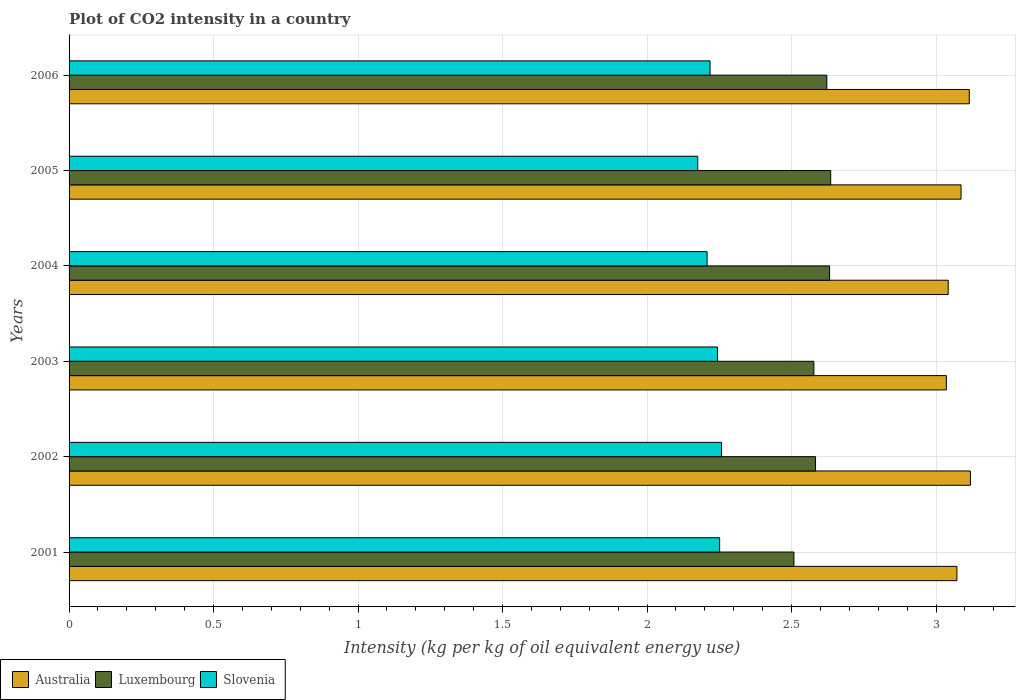How many groups of bars are there?
Your response must be concise. 6. Are the number of bars on each tick of the Y-axis equal?
Give a very brief answer. Yes. How many bars are there on the 3rd tick from the top?
Your answer should be compact. 3. In how many cases, is the number of bars for a given year not equal to the number of legend labels?
Ensure brevity in your answer.  0. What is the CO2 intensity in in Australia in 2001?
Keep it short and to the point. 3.07. Across all years, what is the maximum CO2 intensity in in Australia?
Your response must be concise. 3.12. Across all years, what is the minimum CO2 intensity in in Luxembourg?
Ensure brevity in your answer.  2.51. In which year was the CO2 intensity in in Luxembourg maximum?
Offer a very short reply. 2005. What is the total CO2 intensity in in Australia in the graph?
Your answer should be compact. 18.47. What is the difference between the CO2 intensity in in Slovenia in 2002 and that in 2006?
Your answer should be very brief. 0.04. What is the difference between the CO2 intensity in in Luxembourg in 2004 and the CO2 intensity in in Slovenia in 2006?
Offer a very short reply. 0.41. What is the average CO2 intensity in in Australia per year?
Provide a succinct answer. 3.08. In the year 2004, what is the difference between the CO2 intensity in in Luxembourg and CO2 intensity in in Australia?
Give a very brief answer. -0.41. What is the ratio of the CO2 intensity in in Slovenia in 2004 to that in 2006?
Ensure brevity in your answer.  1. Is the CO2 intensity in in Luxembourg in 2001 less than that in 2003?
Provide a succinct answer. Yes. What is the difference between the highest and the second highest CO2 intensity in in Luxembourg?
Provide a succinct answer. 0. What is the difference between the highest and the lowest CO2 intensity in in Australia?
Offer a very short reply. 0.08. In how many years, is the CO2 intensity in in Australia greater than the average CO2 intensity in in Australia taken over all years?
Ensure brevity in your answer.  3. What does the 2nd bar from the top in 2003 represents?
Provide a short and direct response. Luxembourg. What does the 2nd bar from the bottom in 2003 represents?
Your response must be concise. Luxembourg. Is it the case that in every year, the sum of the CO2 intensity in in Australia and CO2 intensity in in Luxembourg is greater than the CO2 intensity in in Slovenia?
Keep it short and to the point. Yes. Are all the bars in the graph horizontal?
Your response must be concise. Yes. What is the difference between two consecutive major ticks on the X-axis?
Make the answer very short. 0.5. Where does the legend appear in the graph?
Make the answer very short. Bottom left. How many legend labels are there?
Keep it short and to the point. 3. How are the legend labels stacked?
Ensure brevity in your answer.  Horizontal. What is the title of the graph?
Ensure brevity in your answer.  Plot of CO2 intensity in a country. What is the label or title of the X-axis?
Provide a short and direct response. Intensity (kg per kg of oil equivalent energy use). What is the label or title of the Y-axis?
Offer a very short reply. Years. What is the Intensity (kg per kg of oil equivalent energy use) in Australia in 2001?
Your answer should be compact. 3.07. What is the Intensity (kg per kg of oil equivalent energy use) of Luxembourg in 2001?
Your response must be concise. 2.51. What is the Intensity (kg per kg of oil equivalent energy use) of Slovenia in 2001?
Provide a short and direct response. 2.25. What is the Intensity (kg per kg of oil equivalent energy use) in Australia in 2002?
Keep it short and to the point. 3.12. What is the Intensity (kg per kg of oil equivalent energy use) in Luxembourg in 2002?
Make the answer very short. 2.58. What is the Intensity (kg per kg of oil equivalent energy use) of Slovenia in 2002?
Provide a short and direct response. 2.26. What is the Intensity (kg per kg of oil equivalent energy use) of Australia in 2003?
Keep it short and to the point. 3.04. What is the Intensity (kg per kg of oil equivalent energy use) of Luxembourg in 2003?
Make the answer very short. 2.58. What is the Intensity (kg per kg of oil equivalent energy use) in Slovenia in 2003?
Your response must be concise. 2.24. What is the Intensity (kg per kg of oil equivalent energy use) of Australia in 2004?
Your answer should be compact. 3.04. What is the Intensity (kg per kg of oil equivalent energy use) of Luxembourg in 2004?
Your answer should be compact. 2.63. What is the Intensity (kg per kg of oil equivalent energy use) in Slovenia in 2004?
Give a very brief answer. 2.21. What is the Intensity (kg per kg of oil equivalent energy use) of Australia in 2005?
Ensure brevity in your answer.  3.09. What is the Intensity (kg per kg of oil equivalent energy use) in Luxembourg in 2005?
Offer a terse response. 2.64. What is the Intensity (kg per kg of oil equivalent energy use) in Slovenia in 2005?
Provide a succinct answer. 2.18. What is the Intensity (kg per kg of oil equivalent energy use) of Australia in 2006?
Offer a terse response. 3.12. What is the Intensity (kg per kg of oil equivalent energy use) in Luxembourg in 2006?
Your answer should be very brief. 2.62. What is the Intensity (kg per kg of oil equivalent energy use) of Slovenia in 2006?
Keep it short and to the point. 2.22. Across all years, what is the maximum Intensity (kg per kg of oil equivalent energy use) in Australia?
Give a very brief answer. 3.12. Across all years, what is the maximum Intensity (kg per kg of oil equivalent energy use) of Luxembourg?
Make the answer very short. 2.64. Across all years, what is the maximum Intensity (kg per kg of oil equivalent energy use) of Slovenia?
Your answer should be very brief. 2.26. Across all years, what is the minimum Intensity (kg per kg of oil equivalent energy use) of Australia?
Keep it short and to the point. 3.04. Across all years, what is the minimum Intensity (kg per kg of oil equivalent energy use) in Luxembourg?
Your answer should be compact. 2.51. Across all years, what is the minimum Intensity (kg per kg of oil equivalent energy use) in Slovenia?
Provide a succinct answer. 2.18. What is the total Intensity (kg per kg of oil equivalent energy use) in Australia in the graph?
Keep it short and to the point. 18.47. What is the total Intensity (kg per kg of oil equivalent energy use) in Luxembourg in the graph?
Offer a terse response. 15.56. What is the total Intensity (kg per kg of oil equivalent energy use) in Slovenia in the graph?
Your response must be concise. 13.35. What is the difference between the Intensity (kg per kg of oil equivalent energy use) in Australia in 2001 and that in 2002?
Ensure brevity in your answer.  -0.05. What is the difference between the Intensity (kg per kg of oil equivalent energy use) of Luxembourg in 2001 and that in 2002?
Provide a short and direct response. -0.07. What is the difference between the Intensity (kg per kg of oil equivalent energy use) in Slovenia in 2001 and that in 2002?
Ensure brevity in your answer.  -0.01. What is the difference between the Intensity (kg per kg of oil equivalent energy use) in Australia in 2001 and that in 2003?
Your response must be concise. 0.04. What is the difference between the Intensity (kg per kg of oil equivalent energy use) of Luxembourg in 2001 and that in 2003?
Make the answer very short. -0.07. What is the difference between the Intensity (kg per kg of oil equivalent energy use) in Slovenia in 2001 and that in 2003?
Ensure brevity in your answer.  0.01. What is the difference between the Intensity (kg per kg of oil equivalent energy use) of Australia in 2001 and that in 2004?
Give a very brief answer. 0.03. What is the difference between the Intensity (kg per kg of oil equivalent energy use) in Luxembourg in 2001 and that in 2004?
Offer a very short reply. -0.12. What is the difference between the Intensity (kg per kg of oil equivalent energy use) of Slovenia in 2001 and that in 2004?
Keep it short and to the point. 0.04. What is the difference between the Intensity (kg per kg of oil equivalent energy use) of Australia in 2001 and that in 2005?
Offer a terse response. -0.01. What is the difference between the Intensity (kg per kg of oil equivalent energy use) of Luxembourg in 2001 and that in 2005?
Provide a short and direct response. -0.13. What is the difference between the Intensity (kg per kg of oil equivalent energy use) in Slovenia in 2001 and that in 2005?
Your response must be concise. 0.08. What is the difference between the Intensity (kg per kg of oil equivalent energy use) in Australia in 2001 and that in 2006?
Offer a very short reply. -0.04. What is the difference between the Intensity (kg per kg of oil equivalent energy use) in Luxembourg in 2001 and that in 2006?
Provide a succinct answer. -0.11. What is the difference between the Intensity (kg per kg of oil equivalent energy use) in Slovenia in 2001 and that in 2006?
Offer a very short reply. 0.03. What is the difference between the Intensity (kg per kg of oil equivalent energy use) in Australia in 2002 and that in 2003?
Keep it short and to the point. 0.08. What is the difference between the Intensity (kg per kg of oil equivalent energy use) in Luxembourg in 2002 and that in 2003?
Provide a short and direct response. 0.01. What is the difference between the Intensity (kg per kg of oil equivalent energy use) of Slovenia in 2002 and that in 2003?
Keep it short and to the point. 0.01. What is the difference between the Intensity (kg per kg of oil equivalent energy use) of Australia in 2002 and that in 2004?
Provide a succinct answer. 0.08. What is the difference between the Intensity (kg per kg of oil equivalent energy use) in Luxembourg in 2002 and that in 2004?
Provide a succinct answer. -0.05. What is the difference between the Intensity (kg per kg of oil equivalent energy use) of Slovenia in 2002 and that in 2004?
Your answer should be compact. 0.05. What is the difference between the Intensity (kg per kg of oil equivalent energy use) of Australia in 2002 and that in 2005?
Offer a terse response. 0.03. What is the difference between the Intensity (kg per kg of oil equivalent energy use) in Luxembourg in 2002 and that in 2005?
Your answer should be very brief. -0.05. What is the difference between the Intensity (kg per kg of oil equivalent energy use) in Slovenia in 2002 and that in 2005?
Offer a very short reply. 0.08. What is the difference between the Intensity (kg per kg of oil equivalent energy use) of Australia in 2002 and that in 2006?
Offer a terse response. 0. What is the difference between the Intensity (kg per kg of oil equivalent energy use) of Luxembourg in 2002 and that in 2006?
Your answer should be compact. -0.04. What is the difference between the Intensity (kg per kg of oil equivalent energy use) of Slovenia in 2002 and that in 2006?
Ensure brevity in your answer.  0.04. What is the difference between the Intensity (kg per kg of oil equivalent energy use) of Australia in 2003 and that in 2004?
Give a very brief answer. -0.01. What is the difference between the Intensity (kg per kg of oil equivalent energy use) of Luxembourg in 2003 and that in 2004?
Provide a succinct answer. -0.05. What is the difference between the Intensity (kg per kg of oil equivalent energy use) in Slovenia in 2003 and that in 2004?
Your answer should be compact. 0.04. What is the difference between the Intensity (kg per kg of oil equivalent energy use) in Australia in 2003 and that in 2005?
Provide a short and direct response. -0.05. What is the difference between the Intensity (kg per kg of oil equivalent energy use) in Luxembourg in 2003 and that in 2005?
Keep it short and to the point. -0.06. What is the difference between the Intensity (kg per kg of oil equivalent energy use) in Slovenia in 2003 and that in 2005?
Offer a terse response. 0.07. What is the difference between the Intensity (kg per kg of oil equivalent energy use) in Australia in 2003 and that in 2006?
Offer a very short reply. -0.08. What is the difference between the Intensity (kg per kg of oil equivalent energy use) of Luxembourg in 2003 and that in 2006?
Ensure brevity in your answer.  -0.04. What is the difference between the Intensity (kg per kg of oil equivalent energy use) in Slovenia in 2003 and that in 2006?
Provide a short and direct response. 0.03. What is the difference between the Intensity (kg per kg of oil equivalent energy use) of Australia in 2004 and that in 2005?
Give a very brief answer. -0.04. What is the difference between the Intensity (kg per kg of oil equivalent energy use) of Luxembourg in 2004 and that in 2005?
Your answer should be very brief. -0. What is the difference between the Intensity (kg per kg of oil equivalent energy use) of Slovenia in 2004 and that in 2005?
Your answer should be compact. 0.03. What is the difference between the Intensity (kg per kg of oil equivalent energy use) of Australia in 2004 and that in 2006?
Provide a succinct answer. -0.07. What is the difference between the Intensity (kg per kg of oil equivalent energy use) in Luxembourg in 2004 and that in 2006?
Ensure brevity in your answer.  0.01. What is the difference between the Intensity (kg per kg of oil equivalent energy use) of Slovenia in 2004 and that in 2006?
Offer a terse response. -0.01. What is the difference between the Intensity (kg per kg of oil equivalent energy use) in Australia in 2005 and that in 2006?
Your answer should be compact. -0.03. What is the difference between the Intensity (kg per kg of oil equivalent energy use) of Luxembourg in 2005 and that in 2006?
Provide a succinct answer. 0.01. What is the difference between the Intensity (kg per kg of oil equivalent energy use) of Slovenia in 2005 and that in 2006?
Your response must be concise. -0.04. What is the difference between the Intensity (kg per kg of oil equivalent energy use) in Australia in 2001 and the Intensity (kg per kg of oil equivalent energy use) in Luxembourg in 2002?
Your answer should be very brief. 0.49. What is the difference between the Intensity (kg per kg of oil equivalent energy use) in Australia in 2001 and the Intensity (kg per kg of oil equivalent energy use) in Slovenia in 2002?
Give a very brief answer. 0.81. What is the difference between the Intensity (kg per kg of oil equivalent energy use) of Luxembourg in 2001 and the Intensity (kg per kg of oil equivalent energy use) of Slovenia in 2002?
Give a very brief answer. 0.25. What is the difference between the Intensity (kg per kg of oil equivalent energy use) in Australia in 2001 and the Intensity (kg per kg of oil equivalent energy use) in Luxembourg in 2003?
Your answer should be compact. 0.49. What is the difference between the Intensity (kg per kg of oil equivalent energy use) of Australia in 2001 and the Intensity (kg per kg of oil equivalent energy use) of Slovenia in 2003?
Give a very brief answer. 0.83. What is the difference between the Intensity (kg per kg of oil equivalent energy use) of Luxembourg in 2001 and the Intensity (kg per kg of oil equivalent energy use) of Slovenia in 2003?
Make the answer very short. 0.26. What is the difference between the Intensity (kg per kg of oil equivalent energy use) of Australia in 2001 and the Intensity (kg per kg of oil equivalent energy use) of Luxembourg in 2004?
Offer a very short reply. 0.44. What is the difference between the Intensity (kg per kg of oil equivalent energy use) in Australia in 2001 and the Intensity (kg per kg of oil equivalent energy use) in Slovenia in 2004?
Offer a very short reply. 0.86. What is the difference between the Intensity (kg per kg of oil equivalent energy use) of Luxembourg in 2001 and the Intensity (kg per kg of oil equivalent energy use) of Slovenia in 2004?
Provide a short and direct response. 0.3. What is the difference between the Intensity (kg per kg of oil equivalent energy use) of Australia in 2001 and the Intensity (kg per kg of oil equivalent energy use) of Luxembourg in 2005?
Ensure brevity in your answer.  0.44. What is the difference between the Intensity (kg per kg of oil equivalent energy use) of Australia in 2001 and the Intensity (kg per kg of oil equivalent energy use) of Slovenia in 2005?
Provide a succinct answer. 0.9. What is the difference between the Intensity (kg per kg of oil equivalent energy use) of Luxembourg in 2001 and the Intensity (kg per kg of oil equivalent energy use) of Slovenia in 2005?
Make the answer very short. 0.33. What is the difference between the Intensity (kg per kg of oil equivalent energy use) of Australia in 2001 and the Intensity (kg per kg of oil equivalent energy use) of Luxembourg in 2006?
Your response must be concise. 0.45. What is the difference between the Intensity (kg per kg of oil equivalent energy use) of Australia in 2001 and the Intensity (kg per kg of oil equivalent energy use) of Slovenia in 2006?
Offer a very short reply. 0.85. What is the difference between the Intensity (kg per kg of oil equivalent energy use) in Luxembourg in 2001 and the Intensity (kg per kg of oil equivalent energy use) in Slovenia in 2006?
Your answer should be compact. 0.29. What is the difference between the Intensity (kg per kg of oil equivalent energy use) in Australia in 2002 and the Intensity (kg per kg of oil equivalent energy use) in Luxembourg in 2003?
Your answer should be very brief. 0.54. What is the difference between the Intensity (kg per kg of oil equivalent energy use) in Australia in 2002 and the Intensity (kg per kg of oil equivalent energy use) in Slovenia in 2003?
Give a very brief answer. 0.88. What is the difference between the Intensity (kg per kg of oil equivalent energy use) of Luxembourg in 2002 and the Intensity (kg per kg of oil equivalent energy use) of Slovenia in 2003?
Your answer should be compact. 0.34. What is the difference between the Intensity (kg per kg of oil equivalent energy use) of Australia in 2002 and the Intensity (kg per kg of oil equivalent energy use) of Luxembourg in 2004?
Provide a succinct answer. 0.49. What is the difference between the Intensity (kg per kg of oil equivalent energy use) in Australia in 2002 and the Intensity (kg per kg of oil equivalent energy use) in Slovenia in 2004?
Offer a very short reply. 0.91. What is the difference between the Intensity (kg per kg of oil equivalent energy use) of Luxembourg in 2002 and the Intensity (kg per kg of oil equivalent energy use) of Slovenia in 2004?
Your answer should be very brief. 0.38. What is the difference between the Intensity (kg per kg of oil equivalent energy use) of Australia in 2002 and the Intensity (kg per kg of oil equivalent energy use) of Luxembourg in 2005?
Provide a succinct answer. 0.48. What is the difference between the Intensity (kg per kg of oil equivalent energy use) in Australia in 2002 and the Intensity (kg per kg of oil equivalent energy use) in Slovenia in 2005?
Keep it short and to the point. 0.94. What is the difference between the Intensity (kg per kg of oil equivalent energy use) in Luxembourg in 2002 and the Intensity (kg per kg of oil equivalent energy use) in Slovenia in 2005?
Ensure brevity in your answer.  0.41. What is the difference between the Intensity (kg per kg of oil equivalent energy use) of Australia in 2002 and the Intensity (kg per kg of oil equivalent energy use) of Luxembourg in 2006?
Ensure brevity in your answer.  0.5. What is the difference between the Intensity (kg per kg of oil equivalent energy use) in Australia in 2002 and the Intensity (kg per kg of oil equivalent energy use) in Slovenia in 2006?
Offer a very short reply. 0.9. What is the difference between the Intensity (kg per kg of oil equivalent energy use) of Luxembourg in 2002 and the Intensity (kg per kg of oil equivalent energy use) of Slovenia in 2006?
Give a very brief answer. 0.37. What is the difference between the Intensity (kg per kg of oil equivalent energy use) in Australia in 2003 and the Intensity (kg per kg of oil equivalent energy use) in Luxembourg in 2004?
Provide a succinct answer. 0.4. What is the difference between the Intensity (kg per kg of oil equivalent energy use) of Australia in 2003 and the Intensity (kg per kg of oil equivalent energy use) of Slovenia in 2004?
Make the answer very short. 0.83. What is the difference between the Intensity (kg per kg of oil equivalent energy use) in Luxembourg in 2003 and the Intensity (kg per kg of oil equivalent energy use) in Slovenia in 2004?
Your answer should be very brief. 0.37. What is the difference between the Intensity (kg per kg of oil equivalent energy use) of Australia in 2003 and the Intensity (kg per kg of oil equivalent energy use) of Luxembourg in 2005?
Provide a succinct answer. 0.4. What is the difference between the Intensity (kg per kg of oil equivalent energy use) in Australia in 2003 and the Intensity (kg per kg of oil equivalent energy use) in Slovenia in 2005?
Ensure brevity in your answer.  0.86. What is the difference between the Intensity (kg per kg of oil equivalent energy use) in Luxembourg in 2003 and the Intensity (kg per kg of oil equivalent energy use) in Slovenia in 2005?
Provide a short and direct response. 0.4. What is the difference between the Intensity (kg per kg of oil equivalent energy use) of Australia in 2003 and the Intensity (kg per kg of oil equivalent energy use) of Luxembourg in 2006?
Your answer should be compact. 0.41. What is the difference between the Intensity (kg per kg of oil equivalent energy use) of Australia in 2003 and the Intensity (kg per kg of oil equivalent energy use) of Slovenia in 2006?
Provide a succinct answer. 0.82. What is the difference between the Intensity (kg per kg of oil equivalent energy use) in Luxembourg in 2003 and the Intensity (kg per kg of oil equivalent energy use) in Slovenia in 2006?
Ensure brevity in your answer.  0.36. What is the difference between the Intensity (kg per kg of oil equivalent energy use) of Australia in 2004 and the Intensity (kg per kg of oil equivalent energy use) of Luxembourg in 2005?
Make the answer very short. 0.41. What is the difference between the Intensity (kg per kg of oil equivalent energy use) in Australia in 2004 and the Intensity (kg per kg of oil equivalent energy use) in Slovenia in 2005?
Your answer should be very brief. 0.87. What is the difference between the Intensity (kg per kg of oil equivalent energy use) in Luxembourg in 2004 and the Intensity (kg per kg of oil equivalent energy use) in Slovenia in 2005?
Provide a short and direct response. 0.46. What is the difference between the Intensity (kg per kg of oil equivalent energy use) in Australia in 2004 and the Intensity (kg per kg of oil equivalent energy use) in Luxembourg in 2006?
Your answer should be compact. 0.42. What is the difference between the Intensity (kg per kg of oil equivalent energy use) in Australia in 2004 and the Intensity (kg per kg of oil equivalent energy use) in Slovenia in 2006?
Your response must be concise. 0.82. What is the difference between the Intensity (kg per kg of oil equivalent energy use) of Luxembourg in 2004 and the Intensity (kg per kg of oil equivalent energy use) of Slovenia in 2006?
Your answer should be very brief. 0.41. What is the difference between the Intensity (kg per kg of oil equivalent energy use) of Australia in 2005 and the Intensity (kg per kg of oil equivalent energy use) of Luxembourg in 2006?
Offer a very short reply. 0.46. What is the difference between the Intensity (kg per kg of oil equivalent energy use) in Australia in 2005 and the Intensity (kg per kg of oil equivalent energy use) in Slovenia in 2006?
Offer a very short reply. 0.87. What is the difference between the Intensity (kg per kg of oil equivalent energy use) of Luxembourg in 2005 and the Intensity (kg per kg of oil equivalent energy use) of Slovenia in 2006?
Provide a short and direct response. 0.42. What is the average Intensity (kg per kg of oil equivalent energy use) in Australia per year?
Provide a short and direct response. 3.08. What is the average Intensity (kg per kg of oil equivalent energy use) of Luxembourg per year?
Your answer should be very brief. 2.59. What is the average Intensity (kg per kg of oil equivalent energy use) in Slovenia per year?
Offer a very short reply. 2.23. In the year 2001, what is the difference between the Intensity (kg per kg of oil equivalent energy use) of Australia and Intensity (kg per kg of oil equivalent energy use) of Luxembourg?
Make the answer very short. 0.56. In the year 2001, what is the difference between the Intensity (kg per kg of oil equivalent energy use) of Australia and Intensity (kg per kg of oil equivalent energy use) of Slovenia?
Provide a short and direct response. 0.82. In the year 2001, what is the difference between the Intensity (kg per kg of oil equivalent energy use) of Luxembourg and Intensity (kg per kg of oil equivalent energy use) of Slovenia?
Keep it short and to the point. 0.26. In the year 2002, what is the difference between the Intensity (kg per kg of oil equivalent energy use) of Australia and Intensity (kg per kg of oil equivalent energy use) of Luxembourg?
Give a very brief answer. 0.54. In the year 2002, what is the difference between the Intensity (kg per kg of oil equivalent energy use) of Australia and Intensity (kg per kg of oil equivalent energy use) of Slovenia?
Offer a terse response. 0.86. In the year 2002, what is the difference between the Intensity (kg per kg of oil equivalent energy use) of Luxembourg and Intensity (kg per kg of oil equivalent energy use) of Slovenia?
Your answer should be very brief. 0.33. In the year 2003, what is the difference between the Intensity (kg per kg of oil equivalent energy use) in Australia and Intensity (kg per kg of oil equivalent energy use) in Luxembourg?
Keep it short and to the point. 0.46. In the year 2003, what is the difference between the Intensity (kg per kg of oil equivalent energy use) of Australia and Intensity (kg per kg of oil equivalent energy use) of Slovenia?
Offer a very short reply. 0.79. In the year 2004, what is the difference between the Intensity (kg per kg of oil equivalent energy use) of Australia and Intensity (kg per kg of oil equivalent energy use) of Luxembourg?
Offer a very short reply. 0.41. In the year 2004, what is the difference between the Intensity (kg per kg of oil equivalent energy use) in Australia and Intensity (kg per kg of oil equivalent energy use) in Slovenia?
Offer a terse response. 0.83. In the year 2004, what is the difference between the Intensity (kg per kg of oil equivalent energy use) of Luxembourg and Intensity (kg per kg of oil equivalent energy use) of Slovenia?
Ensure brevity in your answer.  0.42. In the year 2005, what is the difference between the Intensity (kg per kg of oil equivalent energy use) of Australia and Intensity (kg per kg of oil equivalent energy use) of Luxembourg?
Offer a terse response. 0.45. In the year 2005, what is the difference between the Intensity (kg per kg of oil equivalent energy use) of Australia and Intensity (kg per kg of oil equivalent energy use) of Slovenia?
Offer a terse response. 0.91. In the year 2005, what is the difference between the Intensity (kg per kg of oil equivalent energy use) of Luxembourg and Intensity (kg per kg of oil equivalent energy use) of Slovenia?
Your answer should be compact. 0.46. In the year 2006, what is the difference between the Intensity (kg per kg of oil equivalent energy use) of Australia and Intensity (kg per kg of oil equivalent energy use) of Luxembourg?
Offer a terse response. 0.49. In the year 2006, what is the difference between the Intensity (kg per kg of oil equivalent energy use) of Australia and Intensity (kg per kg of oil equivalent energy use) of Slovenia?
Offer a terse response. 0.9. In the year 2006, what is the difference between the Intensity (kg per kg of oil equivalent energy use) in Luxembourg and Intensity (kg per kg of oil equivalent energy use) in Slovenia?
Your response must be concise. 0.4. What is the ratio of the Intensity (kg per kg of oil equivalent energy use) of Australia in 2001 to that in 2002?
Offer a very short reply. 0.98. What is the ratio of the Intensity (kg per kg of oil equivalent energy use) of Luxembourg in 2001 to that in 2002?
Make the answer very short. 0.97. What is the ratio of the Intensity (kg per kg of oil equivalent energy use) of Luxembourg in 2001 to that in 2003?
Your response must be concise. 0.97. What is the ratio of the Intensity (kg per kg of oil equivalent energy use) in Australia in 2001 to that in 2004?
Keep it short and to the point. 1.01. What is the ratio of the Intensity (kg per kg of oil equivalent energy use) of Luxembourg in 2001 to that in 2004?
Your answer should be compact. 0.95. What is the ratio of the Intensity (kg per kg of oil equivalent energy use) in Slovenia in 2001 to that in 2004?
Provide a succinct answer. 1.02. What is the ratio of the Intensity (kg per kg of oil equivalent energy use) in Australia in 2001 to that in 2005?
Your response must be concise. 1. What is the ratio of the Intensity (kg per kg of oil equivalent energy use) in Luxembourg in 2001 to that in 2005?
Your response must be concise. 0.95. What is the ratio of the Intensity (kg per kg of oil equivalent energy use) in Slovenia in 2001 to that in 2005?
Make the answer very short. 1.03. What is the ratio of the Intensity (kg per kg of oil equivalent energy use) of Australia in 2001 to that in 2006?
Your answer should be compact. 0.99. What is the ratio of the Intensity (kg per kg of oil equivalent energy use) in Luxembourg in 2001 to that in 2006?
Your answer should be very brief. 0.96. What is the ratio of the Intensity (kg per kg of oil equivalent energy use) in Australia in 2002 to that in 2003?
Your answer should be compact. 1.03. What is the ratio of the Intensity (kg per kg of oil equivalent energy use) of Luxembourg in 2002 to that in 2003?
Your answer should be very brief. 1. What is the ratio of the Intensity (kg per kg of oil equivalent energy use) in Australia in 2002 to that in 2004?
Provide a succinct answer. 1.03. What is the ratio of the Intensity (kg per kg of oil equivalent energy use) in Luxembourg in 2002 to that in 2004?
Make the answer very short. 0.98. What is the ratio of the Intensity (kg per kg of oil equivalent energy use) of Slovenia in 2002 to that in 2004?
Offer a very short reply. 1.02. What is the ratio of the Intensity (kg per kg of oil equivalent energy use) of Australia in 2002 to that in 2005?
Your response must be concise. 1.01. What is the ratio of the Intensity (kg per kg of oil equivalent energy use) in Luxembourg in 2002 to that in 2005?
Your response must be concise. 0.98. What is the ratio of the Intensity (kg per kg of oil equivalent energy use) of Slovenia in 2002 to that in 2005?
Ensure brevity in your answer.  1.04. What is the ratio of the Intensity (kg per kg of oil equivalent energy use) in Australia in 2002 to that in 2006?
Your response must be concise. 1. What is the ratio of the Intensity (kg per kg of oil equivalent energy use) of Luxembourg in 2002 to that in 2006?
Your response must be concise. 0.99. What is the ratio of the Intensity (kg per kg of oil equivalent energy use) of Slovenia in 2002 to that in 2006?
Keep it short and to the point. 1.02. What is the ratio of the Intensity (kg per kg of oil equivalent energy use) in Australia in 2003 to that in 2004?
Provide a short and direct response. 1. What is the ratio of the Intensity (kg per kg of oil equivalent energy use) of Luxembourg in 2003 to that in 2004?
Give a very brief answer. 0.98. What is the ratio of the Intensity (kg per kg of oil equivalent energy use) in Slovenia in 2003 to that in 2004?
Your answer should be compact. 1.02. What is the ratio of the Intensity (kg per kg of oil equivalent energy use) in Australia in 2003 to that in 2005?
Ensure brevity in your answer.  0.98. What is the ratio of the Intensity (kg per kg of oil equivalent energy use) of Luxembourg in 2003 to that in 2005?
Offer a very short reply. 0.98. What is the ratio of the Intensity (kg per kg of oil equivalent energy use) of Slovenia in 2003 to that in 2005?
Ensure brevity in your answer.  1.03. What is the ratio of the Intensity (kg per kg of oil equivalent energy use) of Australia in 2003 to that in 2006?
Provide a succinct answer. 0.97. What is the ratio of the Intensity (kg per kg of oil equivalent energy use) of Luxembourg in 2003 to that in 2006?
Offer a terse response. 0.98. What is the ratio of the Intensity (kg per kg of oil equivalent energy use) in Slovenia in 2003 to that in 2006?
Give a very brief answer. 1.01. What is the ratio of the Intensity (kg per kg of oil equivalent energy use) in Australia in 2004 to that in 2005?
Provide a short and direct response. 0.99. What is the ratio of the Intensity (kg per kg of oil equivalent energy use) of Slovenia in 2004 to that in 2005?
Give a very brief answer. 1.01. What is the ratio of the Intensity (kg per kg of oil equivalent energy use) of Australia in 2004 to that in 2006?
Ensure brevity in your answer.  0.98. What is the ratio of the Intensity (kg per kg of oil equivalent energy use) of Slovenia in 2004 to that in 2006?
Give a very brief answer. 1. What is the ratio of the Intensity (kg per kg of oil equivalent energy use) in Australia in 2005 to that in 2006?
Provide a short and direct response. 0.99. What is the ratio of the Intensity (kg per kg of oil equivalent energy use) in Luxembourg in 2005 to that in 2006?
Offer a terse response. 1.01. What is the ratio of the Intensity (kg per kg of oil equivalent energy use) of Slovenia in 2005 to that in 2006?
Ensure brevity in your answer.  0.98. What is the difference between the highest and the second highest Intensity (kg per kg of oil equivalent energy use) in Australia?
Your answer should be very brief. 0. What is the difference between the highest and the second highest Intensity (kg per kg of oil equivalent energy use) in Luxembourg?
Your answer should be compact. 0. What is the difference between the highest and the second highest Intensity (kg per kg of oil equivalent energy use) of Slovenia?
Provide a succinct answer. 0.01. What is the difference between the highest and the lowest Intensity (kg per kg of oil equivalent energy use) of Australia?
Offer a very short reply. 0.08. What is the difference between the highest and the lowest Intensity (kg per kg of oil equivalent energy use) in Luxembourg?
Your answer should be compact. 0.13. What is the difference between the highest and the lowest Intensity (kg per kg of oil equivalent energy use) in Slovenia?
Make the answer very short. 0.08. 